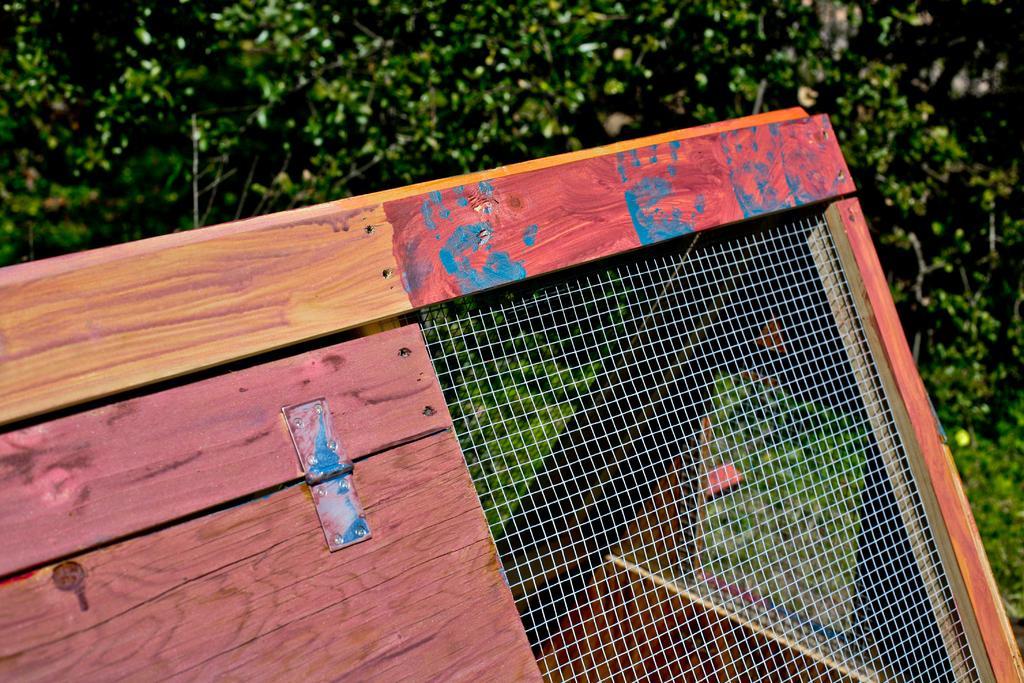In one or two sentences, can you explain what this image depicts? In this image, we can see a wooden door and a net fence. In the background, we can see some trees. 